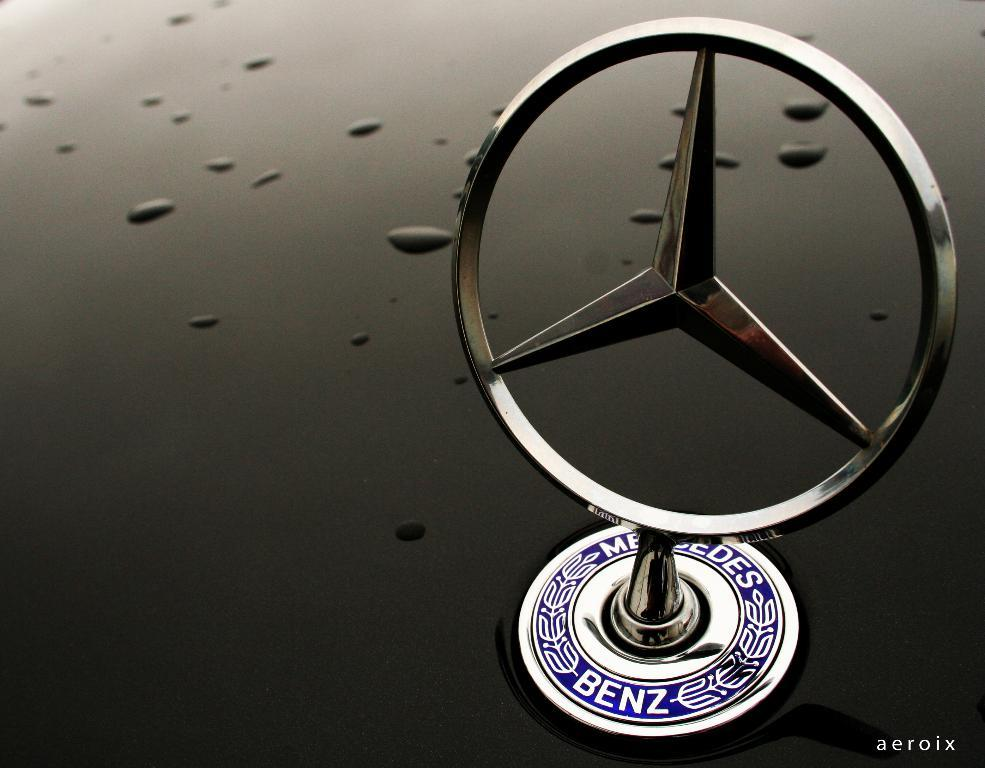What brand logo is visible in the image? The Mercedes Benz logo is visible in the image. What type of plant is growing out of the bread in the image? There is no plant growing out of bread in the image, as the image only features the Mercedes Benz logo. 